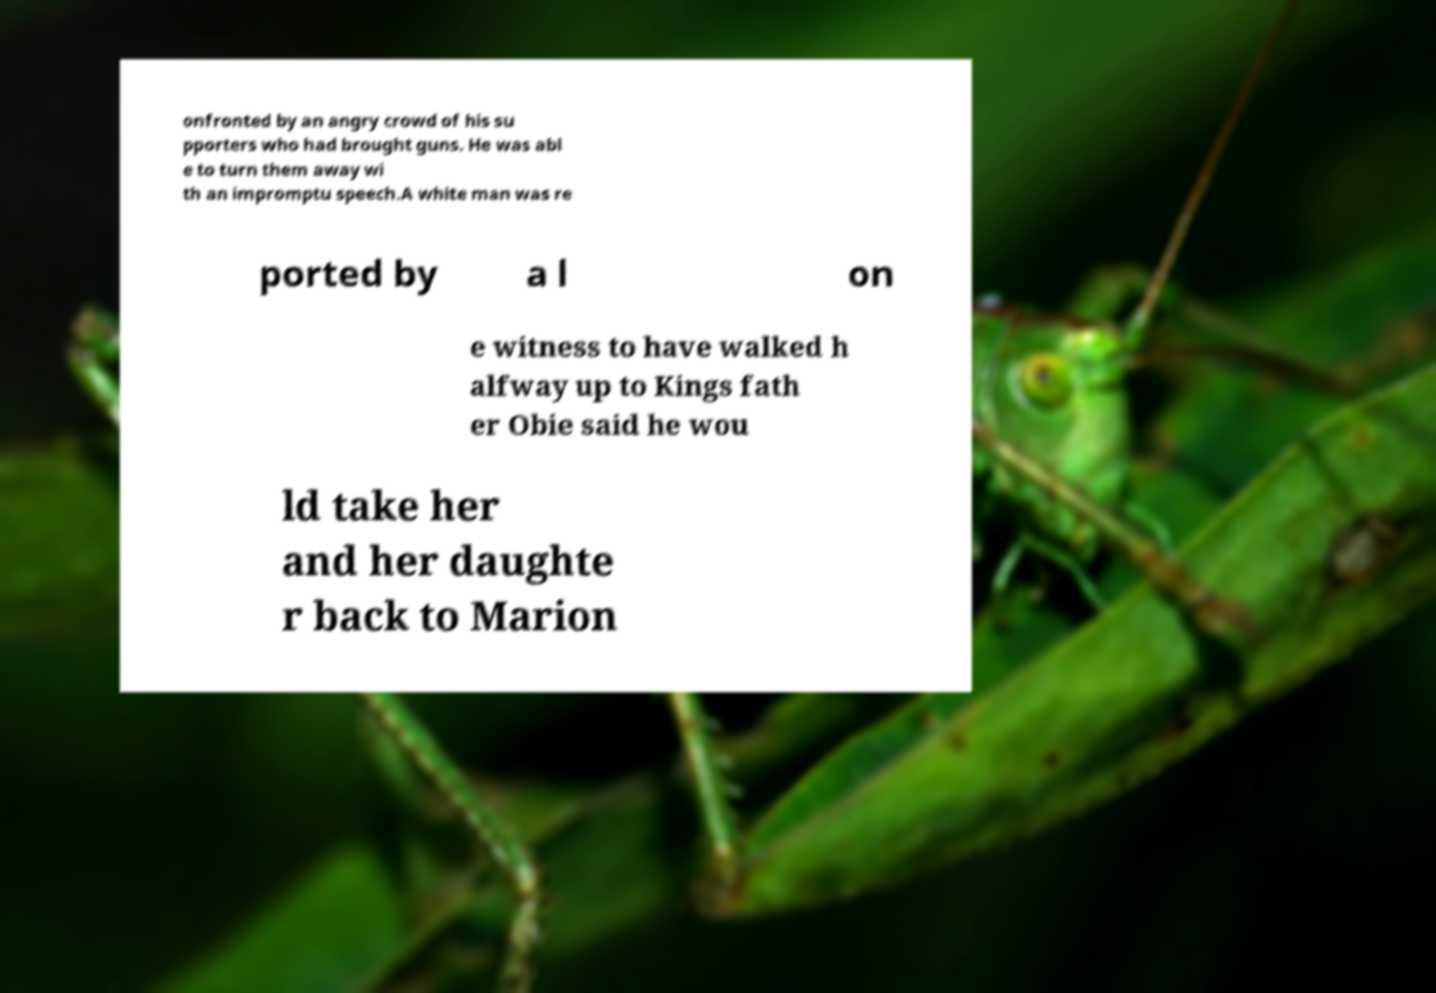What messages or text are displayed in this image? I need them in a readable, typed format. onfronted by an angry crowd of his su pporters who had brought guns. He was abl e to turn them away wi th an impromptu speech.A white man was re ported by a l on e witness to have walked h alfway up to Kings fath er Obie said he wou ld take her and her daughte r back to Marion 